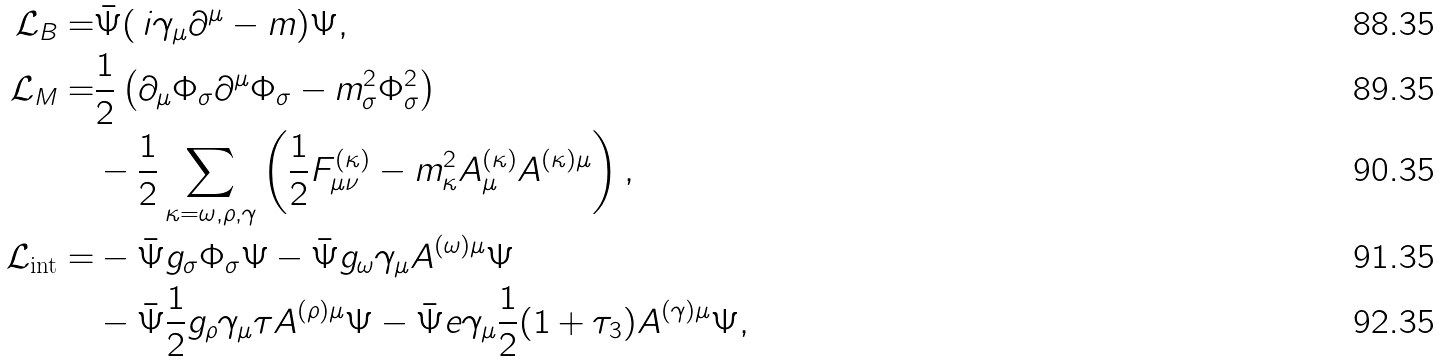<formula> <loc_0><loc_0><loc_500><loc_500>\mathcal { L } _ { B } = & \bar { \Psi } ( \, i \gamma _ { \mu } \partial ^ { \mu } - m ) \Psi , \\ \mathcal { L } _ { M } = & { \frac { 1 } { 2 } } \left ( \partial _ { \mu } \Phi _ { \sigma } \partial ^ { \mu } \Phi _ { \sigma } - m _ { \sigma } ^ { 2 } \Phi _ { \sigma } ^ { 2 } \right ) \\ & - { \frac { 1 } { 2 } } \sum _ { \kappa = \omega , \rho , \gamma } \left ( { \frac { 1 } { 2 } } F _ { \mu \nu } ^ { ( \kappa ) } - m _ { \kappa } ^ { 2 } A _ { \mu } ^ { ( \kappa ) } A ^ { ( \kappa ) \mu } \right ) , \\ \mathcal { L } _ { \text {int} } = & - \bar { \Psi } g _ { \sigma } \Phi _ { \sigma } \Psi - \bar { \Psi } g _ { \omega } \gamma _ { \mu } A ^ { ( \omega ) \mu } \Psi \\ & - \bar { \Psi } { \frac { 1 } { 2 } } g _ { \rho } \gamma _ { \mu } \tau A ^ { ( \rho ) \mu } \Psi - \bar { \Psi } e \gamma _ { \mu } { \frac { 1 } { 2 } } ( 1 + \tau _ { 3 } ) A ^ { ( \gamma ) \mu } \Psi ,</formula> 